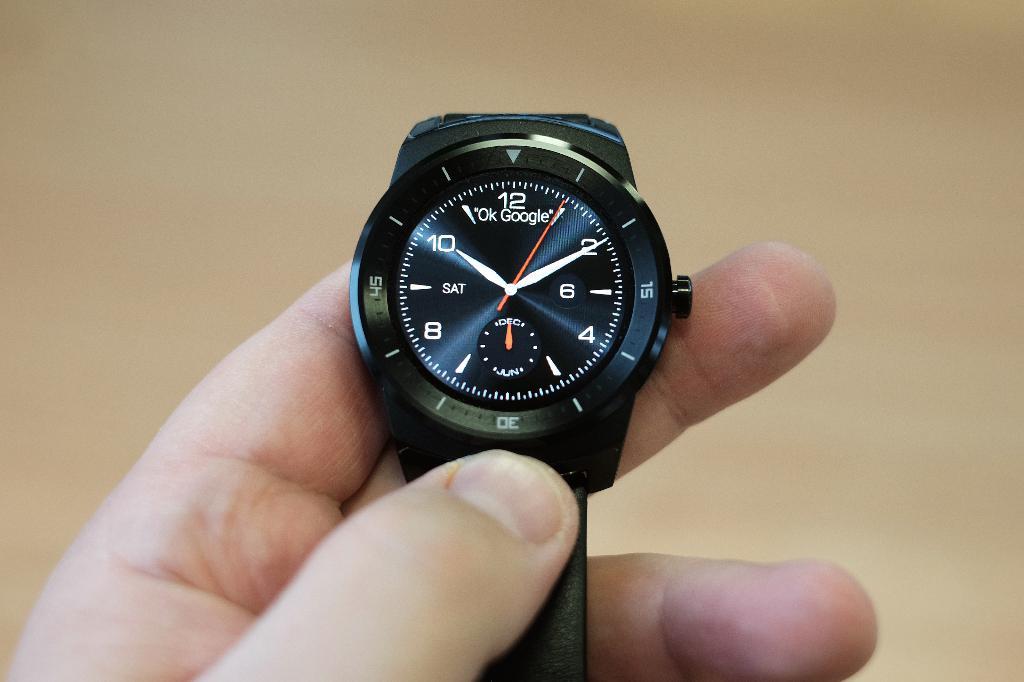What time is shown on the watch?
Give a very brief answer. 10:10. 